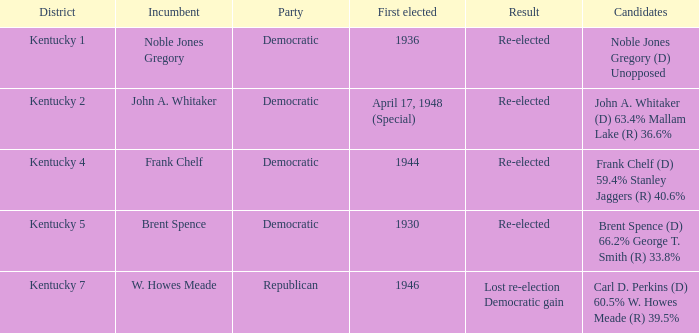Provide a list of all democratic party candidates who participated in an election where frank chelf was the incumbent. Frank Chelf (D) 59.4% Stanley Jaggers (R) 40.6%. 